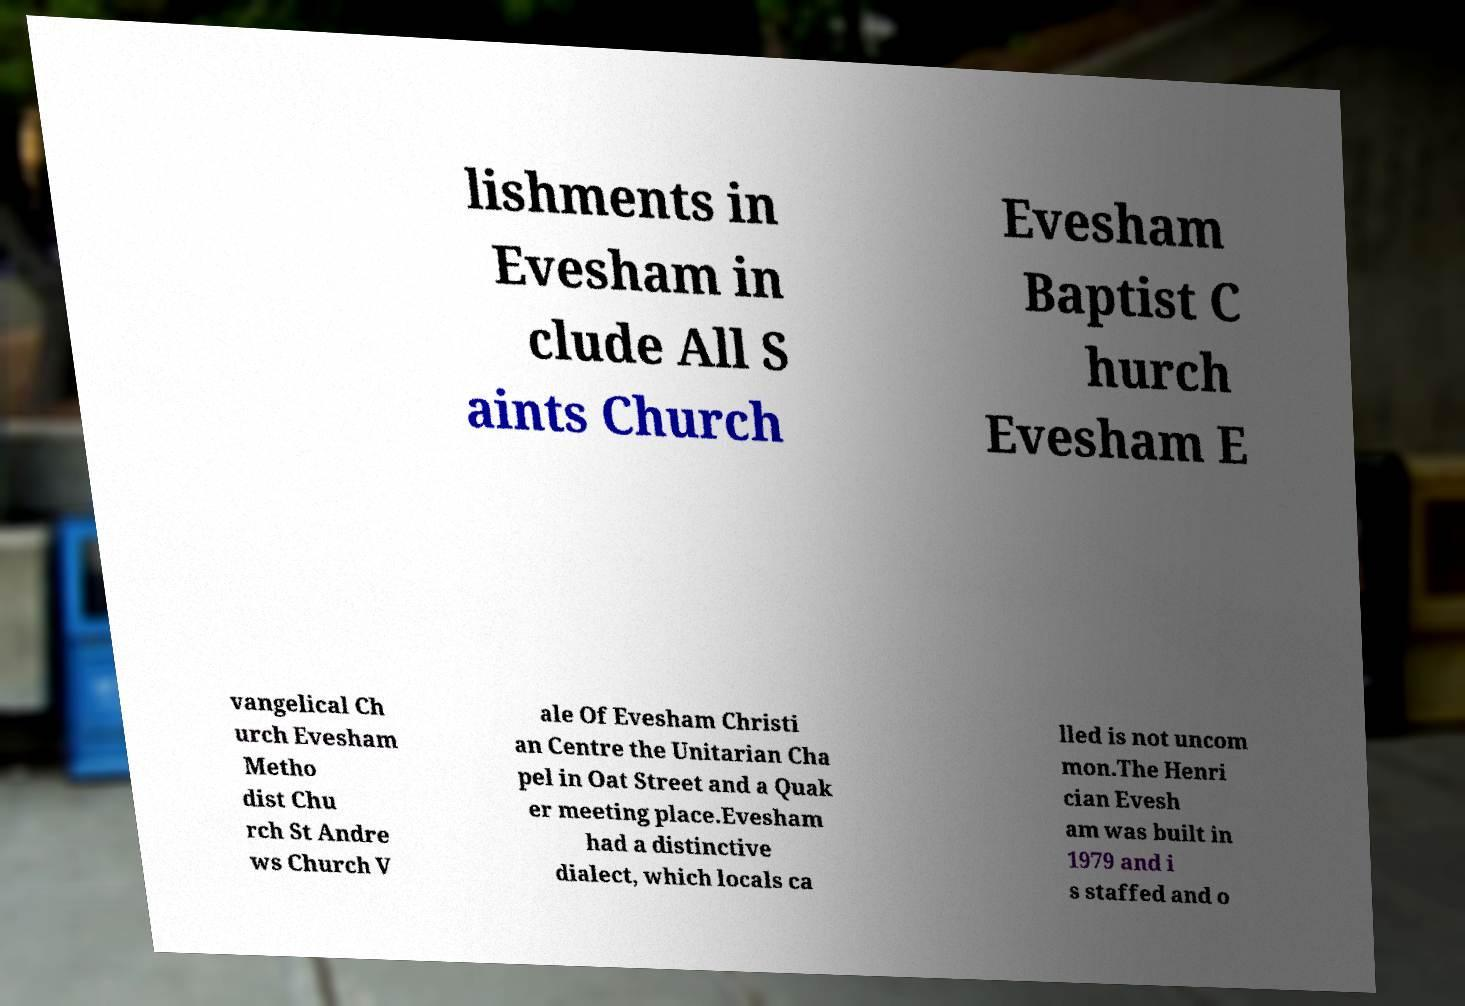I need the written content from this picture converted into text. Can you do that? lishments in Evesham in clude All S aints Church Evesham Baptist C hurch Evesham E vangelical Ch urch Evesham Metho dist Chu rch St Andre ws Church V ale Of Evesham Christi an Centre the Unitarian Cha pel in Oat Street and a Quak er meeting place.Evesham had a distinctive dialect, which locals ca lled is not uncom mon.The Henri cian Evesh am was built in 1979 and i s staffed and o 